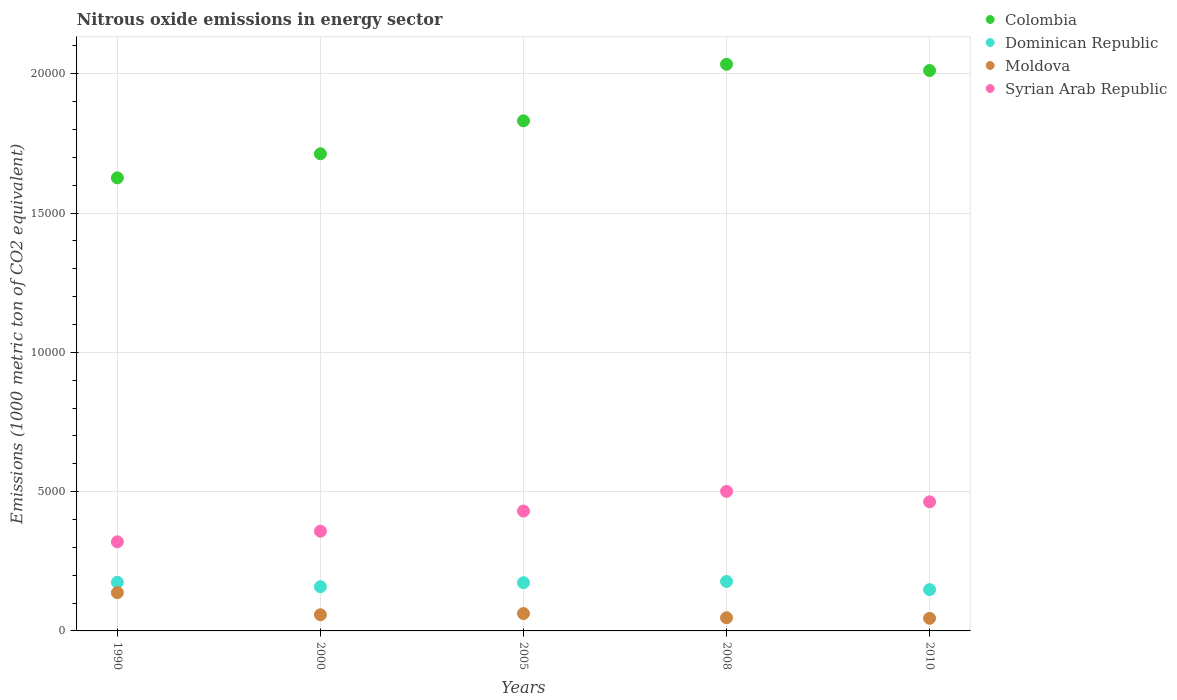How many different coloured dotlines are there?
Keep it short and to the point. 4. What is the amount of nitrous oxide emitted in Dominican Republic in 2005?
Your answer should be compact. 1731. Across all years, what is the maximum amount of nitrous oxide emitted in Moldova?
Give a very brief answer. 1373.3. Across all years, what is the minimum amount of nitrous oxide emitted in Dominican Republic?
Make the answer very short. 1481.5. In which year was the amount of nitrous oxide emitted in Colombia minimum?
Your answer should be very brief. 1990. What is the total amount of nitrous oxide emitted in Moldova in the graph?
Your response must be concise. 3502.6. What is the difference between the amount of nitrous oxide emitted in Colombia in 1990 and that in 2008?
Make the answer very short. -4077.5. What is the difference between the amount of nitrous oxide emitted in Colombia in 2005 and the amount of nitrous oxide emitted in Syrian Arab Republic in 2010?
Your response must be concise. 1.37e+04. What is the average amount of nitrous oxide emitted in Syrian Arab Republic per year?
Ensure brevity in your answer.  4144.66. In the year 2010, what is the difference between the amount of nitrous oxide emitted in Colombia and amount of nitrous oxide emitted in Syrian Arab Republic?
Give a very brief answer. 1.55e+04. In how many years, is the amount of nitrous oxide emitted in Syrian Arab Republic greater than 3000 1000 metric ton?
Keep it short and to the point. 5. What is the ratio of the amount of nitrous oxide emitted in Dominican Republic in 2005 to that in 2008?
Your answer should be very brief. 0.97. What is the difference between the highest and the second highest amount of nitrous oxide emitted in Syrian Arab Republic?
Your answer should be very brief. 376.8. What is the difference between the highest and the lowest amount of nitrous oxide emitted in Syrian Arab Republic?
Your answer should be compact. 1811.4. In how many years, is the amount of nitrous oxide emitted in Moldova greater than the average amount of nitrous oxide emitted in Moldova taken over all years?
Your answer should be very brief. 1. Is it the case that in every year, the sum of the amount of nitrous oxide emitted in Moldova and amount of nitrous oxide emitted in Dominican Republic  is greater than the sum of amount of nitrous oxide emitted in Colombia and amount of nitrous oxide emitted in Syrian Arab Republic?
Provide a succinct answer. No. Is it the case that in every year, the sum of the amount of nitrous oxide emitted in Moldova and amount of nitrous oxide emitted in Dominican Republic  is greater than the amount of nitrous oxide emitted in Syrian Arab Republic?
Ensure brevity in your answer.  No. Does the graph contain grids?
Give a very brief answer. Yes. How many legend labels are there?
Offer a terse response. 4. How are the legend labels stacked?
Your answer should be compact. Vertical. What is the title of the graph?
Your response must be concise. Nitrous oxide emissions in energy sector. What is the label or title of the Y-axis?
Provide a short and direct response. Emissions (1000 metric ton of CO2 equivalent). What is the Emissions (1000 metric ton of CO2 equivalent) in Colombia in 1990?
Offer a terse response. 1.63e+04. What is the Emissions (1000 metric ton of CO2 equivalent) in Dominican Republic in 1990?
Offer a very short reply. 1746.5. What is the Emissions (1000 metric ton of CO2 equivalent) of Moldova in 1990?
Your answer should be compact. 1373.3. What is the Emissions (1000 metric ton of CO2 equivalent) in Syrian Arab Republic in 1990?
Give a very brief answer. 3198.5. What is the Emissions (1000 metric ton of CO2 equivalent) of Colombia in 2000?
Offer a terse response. 1.71e+04. What is the Emissions (1000 metric ton of CO2 equivalent) of Dominican Republic in 2000?
Your answer should be compact. 1586.4. What is the Emissions (1000 metric ton of CO2 equivalent) in Moldova in 2000?
Provide a short and direct response. 579.9. What is the Emissions (1000 metric ton of CO2 equivalent) of Syrian Arab Republic in 2000?
Keep it short and to the point. 3579.1. What is the Emissions (1000 metric ton of CO2 equivalent) in Colombia in 2005?
Ensure brevity in your answer.  1.83e+04. What is the Emissions (1000 metric ton of CO2 equivalent) in Dominican Republic in 2005?
Your answer should be very brief. 1731. What is the Emissions (1000 metric ton of CO2 equivalent) of Moldova in 2005?
Provide a succinct answer. 624.1. What is the Emissions (1000 metric ton of CO2 equivalent) in Syrian Arab Republic in 2005?
Give a very brief answer. 4302.7. What is the Emissions (1000 metric ton of CO2 equivalent) of Colombia in 2008?
Your response must be concise. 2.03e+04. What is the Emissions (1000 metric ton of CO2 equivalent) of Dominican Republic in 2008?
Offer a very short reply. 1775.7. What is the Emissions (1000 metric ton of CO2 equivalent) in Moldova in 2008?
Your answer should be compact. 472.4. What is the Emissions (1000 metric ton of CO2 equivalent) of Syrian Arab Republic in 2008?
Provide a succinct answer. 5009.9. What is the Emissions (1000 metric ton of CO2 equivalent) of Colombia in 2010?
Offer a terse response. 2.01e+04. What is the Emissions (1000 metric ton of CO2 equivalent) of Dominican Republic in 2010?
Make the answer very short. 1481.5. What is the Emissions (1000 metric ton of CO2 equivalent) of Moldova in 2010?
Your answer should be very brief. 452.9. What is the Emissions (1000 metric ton of CO2 equivalent) in Syrian Arab Republic in 2010?
Your response must be concise. 4633.1. Across all years, what is the maximum Emissions (1000 metric ton of CO2 equivalent) of Colombia?
Ensure brevity in your answer.  2.03e+04. Across all years, what is the maximum Emissions (1000 metric ton of CO2 equivalent) of Dominican Republic?
Give a very brief answer. 1775.7. Across all years, what is the maximum Emissions (1000 metric ton of CO2 equivalent) in Moldova?
Make the answer very short. 1373.3. Across all years, what is the maximum Emissions (1000 metric ton of CO2 equivalent) in Syrian Arab Republic?
Offer a terse response. 5009.9. Across all years, what is the minimum Emissions (1000 metric ton of CO2 equivalent) of Colombia?
Ensure brevity in your answer.  1.63e+04. Across all years, what is the minimum Emissions (1000 metric ton of CO2 equivalent) in Dominican Republic?
Provide a succinct answer. 1481.5. Across all years, what is the minimum Emissions (1000 metric ton of CO2 equivalent) in Moldova?
Give a very brief answer. 452.9. Across all years, what is the minimum Emissions (1000 metric ton of CO2 equivalent) of Syrian Arab Republic?
Give a very brief answer. 3198.5. What is the total Emissions (1000 metric ton of CO2 equivalent) of Colombia in the graph?
Ensure brevity in your answer.  9.22e+04. What is the total Emissions (1000 metric ton of CO2 equivalent) of Dominican Republic in the graph?
Make the answer very short. 8321.1. What is the total Emissions (1000 metric ton of CO2 equivalent) in Moldova in the graph?
Provide a succinct answer. 3502.6. What is the total Emissions (1000 metric ton of CO2 equivalent) in Syrian Arab Republic in the graph?
Offer a very short reply. 2.07e+04. What is the difference between the Emissions (1000 metric ton of CO2 equivalent) in Colombia in 1990 and that in 2000?
Ensure brevity in your answer.  -864.4. What is the difference between the Emissions (1000 metric ton of CO2 equivalent) in Dominican Republic in 1990 and that in 2000?
Give a very brief answer. 160.1. What is the difference between the Emissions (1000 metric ton of CO2 equivalent) in Moldova in 1990 and that in 2000?
Keep it short and to the point. 793.4. What is the difference between the Emissions (1000 metric ton of CO2 equivalent) of Syrian Arab Republic in 1990 and that in 2000?
Your response must be concise. -380.6. What is the difference between the Emissions (1000 metric ton of CO2 equivalent) in Colombia in 1990 and that in 2005?
Keep it short and to the point. -2047.6. What is the difference between the Emissions (1000 metric ton of CO2 equivalent) in Moldova in 1990 and that in 2005?
Provide a succinct answer. 749.2. What is the difference between the Emissions (1000 metric ton of CO2 equivalent) in Syrian Arab Republic in 1990 and that in 2005?
Your answer should be very brief. -1104.2. What is the difference between the Emissions (1000 metric ton of CO2 equivalent) of Colombia in 1990 and that in 2008?
Give a very brief answer. -4077.5. What is the difference between the Emissions (1000 metric ton of CO2 equivalent) in Dominican Republic in 1990 and that in 2008?
Provide a succinct answer. -29.2. What is the difference between the Emissions (1000 metric ton of CO2 equivalent) in Moldova in 1990 and that in 2008?
Provide a short and direct response. 900.9. What is the difference between the Emissions (1000 metric ton of CO2 equivalent) in Syrian Arab Republic in 1990 and that in 2008?
Ensure brevity in your answer.  -1811.4. What is the difference between the Emissions (1000 metric ton of CO2 equivalent) in Colombia in 1990 and that in 2010?
Provide a short and direct response. -3854.4. What is the difference between the Emissions (1000 metric ton of CO2 equivalent) of Dominican Republic in 1990 and that in 2010?
Provide a succinct answer. 265. What is the difference between the Emissions (1000 metric ton of CO2 equivalent) of Moldova in 1990 and that in 2010?
Make the answer very short. 920.4. What is the difference between the Emissions (1000 metric ton of CO2 equivalent) in Syrian Arab Republic in 1990 and that in 2010?
Ensure brevity in your answer.  -1434.6. What is the difference between the Emissions (1000 metric ton of CO2 equivalent) in Colombia in 2000 and that in 2005?
Your answer should be very brief. -1183.2. What is the difference between the Emissions (1000 metric ton of CO2 equivalent) in Dominican Republic in 2000 and that in 2005?
Offer a terse response. -144.6. What is the difference between the Emissions (1000 metric ton of CO2 equivalent) of Moldova in 2000 and that in 2005?
Ensure brevity in your answer.  -44.2. What is the difference between the Emissions (1000 metric ton of CO2 equivalent) in Syrian Arab Republic in 2000 and that in 2005?
Your answer should be compact. -723.6. What is the difference between the Emissions (1000 metric ton of CO2 equivalent) in Colombia in 2000 and that in 2008?
Give a very brief answer. -3213.1. What is the difference between the Emissions (1000 metric ton of CO2 equivalent) in Dominican Republic in 2000 and that in 2008?
Give a very brief answer. -189.3. What is the difference between the Emissions (1000 metric ton of CO2 equivalent) in Moldova in 2000 and that in 2008?
Give a very brief answer. 107.5. What is the difference between the Emissions (1000 metric ton of CO2 equivalent) in Syrian Arab Republic in 2000 and that in 2008?
Offer a terse response. -1430.8. What is the difference between the Emissions (1000 metric ton of CO2 equivalent) of Colombia in 2000 and that in 2010?
Keep it short and to the point. -2990. What is the difference between the Emissions (1000 metric ton of CO2 equivalent) of Dominican Republic in 2000 and that in 2010?
Ensure brevity in your answer.  104.9. What is the difference between the Emissions (1000 metric ton of CO2 equivalent) in Moldova in 2000 and that in 2010?
Provide a succinct answer. 127. What is the difference between the Emissions (1000 metric ton of CO2 equivalent) in Syrian Arab Republic in 2000 and that in 2010?
Your answer should be very brief. -1054. What is the difference between the Emissions (1000 metric ton of CO2 equivalent) of Colombia in 2005 and that in 2008?
Make the answer very short. -2029.9. What is the difference between the Emissions (1000 metric ton of CO2 equivalent) of Dominican Republic in 2005 and that in 2008?
Ensure brevity in your answer.  -44.7. What is the difference between the Emissions (1000 metric ton of CO2 equivalent) in Moldova in 2005 and that in 2008?
Make the answer very short. 151.7. What is the difference between the Emissions (1000 metric ton of CO2 equivalent) in Syrian Arab Republic in 2005 and that in 2008?
Provide a short and direct response. -707.2. What is the difference between the Emissions (1000 metric ton of CO2 equivalent) in Colombia in 2005 and that in 2010?
Ensure brevity in your answer.  -1806.8. What is the difference between the Emissions (1000 metric ton of CO2 equivalent) of Dominican Republic in 2005 and that in 2010?
Your answer should be very brief. 249.5. What is the difference between the Emissions (1000 metric ton of CO2 equivalent) of Moldova in 2005 and that in 2010?
Provide a short and direct response. 171.2. What is the difference between the Emissions (1000 metric ton of CO2 equivalent) in Syrian Arab Republic in 2005 and that in 2010?
Offer a very short reply. -330.4. What is the difference between the Emissions (1000 metric ton of CO2 equivalent) in Colombia in 2008 and that in 2010?
Offer a terse response. 223.1. What is the difference between the Emissions (1000 metric ton of CO2 equivalent) in Dominican Republic in 2008 and that in 2010?
Your answer should be very brief. 294.2. What is the difference between the Emissions (1000 metric ton of CO2 equivalent) in Moldova in 2008 and that in 2010?
Offer a terse response. 19.5. What is the difference between the Emissions (1000 metric ton of CO2 equivalent) in Syrian Arab Republic in 2008 and that in 2010?
Your answer should be compact. 376.8. What is the difference between the Emissions (1000 metric ton of CO2 equivalent) of Colombia in 1990 and the Emissions (1000 metric ton of CO2 equivalent) of Dominican Republic in 2000?
Provide a short and direct response. 1.47e+04. What is the difference between the Emissions (1000 metric ton of CO2 equivalent) of Colombia in 1990 and the Emissions (1000 metric ton of CO2 equivalent) of Moldova in 2000?
Provide a succinct answer. 1.57e+04. What is the difference between the Emissions (1000 metric ton of CO2 equivalent) in Colombia in 1990 and the Emissions (1000 metric ton of CO2 equivalent) in Syrian Arab Republic in 2000?
Keep it short and to the point. 1.27e+04. What is the difference between the Emissions (1000 metric ton of CO2 equivalent) in Dominican Republic in 1990 and the Emissions (1000 metric ton of CO2 equivalent) in Moldova in 2000?
Give a very brief answer. 1166.6. What is the difference between the Emissions (1000 metric ton of CO2 equivalent) of Dominican Republic in 1990 and the Emissions (1000 metric ton of CO2 equivalent) of Syrian Arab Republic in 2000?
Provide a succinct answer. -1832.6. What is the difference between the Emissions (1000 metric ton of CO2 equivalent) in Moldova in 1990 and the Emissions (1000 metric ton of CO2 equivalent) in Syrian Arab Republic in 2000?
Provide a succinct answer. -2205.8. What is the difference between the Emissions (1000 metric ton of CO2 equivalent) of Colombia in 1990 and the Emissions (1000 metric ton of CO2 equivalent) of Dominican Republic in 2005?
Offer a terse response. 1.45e+04. What is the difference between the Emissions (1000 metric ton of CO2 equivalent) of Colombia in 1990 and the Emissions (1000 metric ton of CO2 equivalent) of Moldova in 2005?
Give a very brief answer. 1.56e+04. What is the difference between the Emissions (1000 metric ton of CO2 equivalent) of Colombia in 1990 and the Emissions (1000 metric ton of CO2 equivalent) of Syrian Arab Republic in 2005?
Your answer should be compact. 1.20e+04. What is the difference between the Emissions (1000 metric ton of CO2 equivalent) in Dominican Republic in 1990 and the Emissions (1000 metric ton of CO2 equivalent) in Moldova in 2005?
Offer a terse response. 1122.4. What is the difference between the Emissions (1000 metric ton of CO2 equivalent) of Dominican Republic in 1990 and the Emissions (1000 metric ton of CO2 equivalent) of Syrian Arab Republic in 2005?
Your answer should be compact. -2556.2. What is the difference between the Emissions (1000 metric ton of CO2 equivalent) in Moldova in 1990 and the Emissions (1000 metric ton of CO2 equivalent) in Syrian Arab Republic in 2005?
Ensure brevity in your answer.  -2929.4. What is the difference between the Emissions (1000 metric ton of CO2 equivalent) of Colombia in 1990 and the Emissions (1000 metric ton of CO2 equivalent) of Dominican Republic in 2008?
Make the answer very short. 1.45e+04. What is the difference between the Emissions (1000 metric ton of CO2 equivalent) of Colombia in 1990 and the Emissions (1000 metric ton of CO2 equivalent) of Moldova in 2008?
Make the answer very short. 1.58e+04. What is the difference between the Emissions (1000 metric ton of CO2 equivalent) of Colombia in 1990 and the Emissions (1000 metric ton of CO2 equivalent) of Syrian Arab Republic in 2008?
Your answer should be compact. 1.13e+04. What is the difference between the Emissions (1000 metric ton of CO2 equivalent) of Dominican Republic in 1990 and the Emissions (1000 metric ton of CO2 equivalent) of Moldova in 2008?
Your answer should be compact. 1274.1. What is the difference between the Emissions (1000 metric ton of CO2 equivalent) in Dominican Republic in 1990 and the Emissions (1000 metric ton of CO2 equivalent) in Syrian Arab Republic in 2008?
Keep it short and to the point. -3263.4. What is the difference between the Emissions (1000 metric ton of CO2 equivalent) of Moldova in 1990 and the Emissions (1000 metric ton of CO2 equivalent) of Syrian Arab Republic in 2008?
Keep it short and to the point. -3636.6. What is the difference between the Emissions (1000 metric ton of CO2 equivalent) in Colombia in 1990 and the Emissions (1000 metric ton of CO2 equivalent) in Dominican Republic in 2010?
Keep it short and to the point. 1.48e+04. What is the difference between the Emissions (1000 metric ton of CO2 equivalent) of Colombia in 1990 and the Emissions (1000 metric ton of CO2 equivalent) of Moldova in 2010?
Ensure brevity in your answer.  1.58e+04. What is the difference between the Emissions (1000 metric ton of CO2 equivalent) of Colombia in 1990 and the Emissions (1000 metric ton of CO2 equivalent) of Syrian Arab Republic in 2010?
Offer a terse response. 1.16e+04. What is the difference between the Emissions (1000 metric ton of CO2 equivalent) of Dominican Republic in 1990 and the Emissions (1000 metric ton of CO2 equivalent) of Moldova in 2010?
Ensure brevity in your answer.  1293.6. What is the difference between the Emissions (1000 metric ton of CO2 equivalent) of Dominican Republic in 1990 and the Emissions (1000 metric ton of CO2 equivalent) of Syrian Arab Republic in 2010?
Your answer should be very brief. -2886.6. What is the difference between the Emissions (1000 metric ton of CO2 equivalent) in Moldova in 1990 and the Emissions (1000 metric ton of CO2 equivalent) in Syrian Arab Republic in 2010?
Your response must be concise. -3259.8. What is the difference between the Emissions (1000 metric ton of CO2 equivalent) in Colombia in 2000 and the Emissions (1000 metric ton of CO2 equivalent) in Dominican Republic in 2005?
Keep it short and to the point. 1.54e+04. What is the difference between the Emissions (1000 metric ton of CO2 equivalent) of Colombia in 2000 and the Emissions (1000 metric ton of CO2 equivalent) of Moldova in 2005?
Offer a very short reply. 1.65e+04. What is the difference between the Emissions (1000 metric ton of CO2 equivalent) in Colombia in 2000 and the Emissions (1000 metric ton of CO2 equivalent) in Syrian Arab Republic in 2005?
Provide a succinct answer. 1.28e+04. What is the difference between the Emissions (1000 metric ton of CO2 equivalent) in Dominican Republic in 2000 and the Emissions (1000 metric ton of CO2 equivalent) in Moldova in 2005?
Your response must be concise. 962.3. What is the difference between the Emissions (1000 metric ton of CO2 equivalent) of Dominican Republic in 2000 and the Emissions (1000 metric ton of CO2 equivalent) of Syrian Arab Republic in 2005?
Provide a succinct answer. -2716.3. What is the difference between the Emissions (1000 metric ton of CO2 equivalent) in Moldova in 2000 and the Emissions (1000 metric ton of CO2 equivalent) in Syrian Arab Republic in 2005?
Offer a very short reply. -3722.8. What is the difference between the Emissions (1000 metric ton of CO2 equivalent) in Colombia in 2000 and the Emissions (1000 metric ton of CO2 equivalent) in Dominican Republic in 2008?
Ensure brevity in your answer.  1.54e+04. What is the difference between the Emissions (1000 metric ton of CO2 equivalent) in Colombia in 2000 and the Emissions (1000 metric ton of CO2 equivalent) in Moldova in 2008?
Your answer should be very brief. 1.67e+04. What is the difference between the Emissions (1000 metric ton of CO2 equivalent) of Colombia in 2000 and the Emissions (1000 metric ton of CO2 equivalent) of Syrian Arab Republic in 2008?
Offer a terse response. 1.21e+04. What is the difference between the Emissions (1000 metric ton of CO2 equivalent) of Dominican Republic in 2000 and the Emissions (1000 metric ton of CO2 equivalent) of Moldova in 2008?
Make the answer very short. 1114. What is the difference between the Emissions (1000 metric ton of CO2 equivalent) in Dominican Republic in 2000 and the Emissions (1000 metric ton of CO2 equivalent) in Syrian Arab Republic in 2008?
Make the answer very short. -3423.5. What is the difference between the Emissions (1000 metric ton of CO2 equivalent) of Moldova in 2000 and the Emissions (1000 metric ton of CO2 equivalent) of Syrian Arab Republic in 2008?
Ensure brevity in your answer.  -4430. What is the difference between the Emissions (1000 metric ton of CO2 equivalent) in Colombia in 2000 and the Emissions (1000 metric ton of CO2 equivalent) in Dominican Republic in 2010?
Give a very brief answer. 1.56e+04. What is the difference between the Emissions (1000 metric ton of CO2 equivalent) in Colombia in 2000 and the Emissions (1000 metric ton of CO2 equivalent) in Moldova in 2010?
Ensure brevity in your answer.  1.67e+04. What is the difference between the Emissions (1000 metric ton of CO2 equivalent) in Colombia in 2000 and the Emissions (1000 metric ton of CO2 equivalent) in Syrian Arab Republic in 2010?
Give a very brief answer. 1.25e+04. What is the difference between the Emissions (1000 metric ton of CO2 equivalent) of Dominican Republic in 2000 and the Emissions (1000 metric ton of CO2 equivalent) of Moldova in 2010?
Ensure brevity in your answer.  1133.5. What is the difference between the Emissions (1000 metric ton of CO2 equivalent) in Dominican Republic in 2000 and the Emissions (1000 metric ton of CO2 equivalent) in Syrian Arab Republic in 2010?
Your response must be concise. -3046.7. What is the difference between the Emissions (1000 metric ton of CO2 equivalent) in Moldova in 2000 and the Emissions (1000 metric ton of CO2 equivalent) in Syrian Arab Republic in 2010?
Offer a very short reply. -4053.2. What is the difference between the Emissions (1000 metric ton of CO2 equivalent) in Colombia in 2005 and the Emissions (1000 metric ton of CO2 equivalent) in Dominican Republic in 2008?
Give a very brief answer. 1.65e+04. What is the difference between the Emissions (1000 metric ton of CO2 equivalent) in Colombia in 2005 and the Emissions (1000 metric ton of CO2 equivalent) in Moldova in 2008?
Give a very brief answer. 1.78e+04. What is the difference between the Emissions (1000 metric ton of CO2 equivalent) of Colombia in 2005 and the Emissions (1000 metric ton of CO2 equivalent) of Syrian Arab Republic in 2008?
Offer a very short reply. 1.33e+04. What is the difference between the Emissions (1000 metric ton of CO2 equivalent) in Dominican Republic in 2005 and the Emissions (1000 metric ton of CO2 equivalent) in Moldova in 2008?
Provide a succinct answer. 1258.6. What is the difference between the Emissions (1000 metric ton of CO2 equivalent) in Dominican Republic in 2005 and the Emissions (1000 metric ton of CO2 equivalent) in Syrian Arab Republic in 2008?
Give a very brief answer. -3278.9. What is the difference between the Emissions (1000 metric ton of CO2 equivalent) of Moldova in 2005 and the Emissions (1000 metric ton of CO2 equivalent) of Syrian Arab Republic in 2008?
Keep it short and to the point. -4385.8. What is the difference between the Emissions (1000 metric ton of CO2 equivalent) in Colombia in 2005 and the Emissions (1000 metric ton of CO2 equivalent) in Dominican Republic in 2010?
Offer a very short reply. 1.68e+04. What is the difference between the Emissions (1000 metric ton of CO2 equivalent) in Colombia in 2005 and the Emissions (1000 metric ton of CO2 equivalent) in Moldova in 2010?
Your answer should be compact. 1.79e+04. What is the difference between the Emissions (1000 metric ton of CO2 equivalent) of Colombia in 2005 and the Emissions (1000 metric ton of CO2 equivalent) of Syrian Arab Republic in 2010?
Ensure brevity in your answer.  1.37e+04. What is the difference between the Emissions (1000 metric ton of CO2 equivalent) in Dominican Republic in 2005 and the Emissions (1000 metric ton of CO2 equivalent) in Moldova in 2010?
Your answer should be compact. 1278.1. What is the difference between the Emissions (1000 metric ton of CO2 equivalent) in Dominican Republic in 2005 and the Emissions (1000 metric ton of CO2 equivalent) in Syrian Arab Republic in 2010?
Offer a very short reply. -2902.1. What is the difference between the Emissions (1000 metric ton of CO2 equivalent) in Moldova in 2005 and the Emissions (1000 metric ton of CO2 equivalent) in Syrian Arab Republic in 2010?
Your answer should be compact. -4009. What is the difference between the Emissions (1000 metric ton of CO2 equivalent) of Colombia in 2008 and the Emissions (1000 metric ton of CO2 equivalent) of Dominican Republic in 2010?
Your answer should be very brief. 1.89e+04. What is the difference between the Emissions (1000 metric ton of CO2 equivalent) in Colombia in 2008 and the Emissions (1000 metric ton of CO2 equivalent) in Moldova in 2010?
Keep it short and to the point. 1.99e+04. What is the difference between the Emissions (1000 metric ton of CO2 equivalent) in Colombia in 2008 and the Emissions (1000 metric ton of CO2 equivalent) in Syrian Arab Republic in 2010?
Offer a very short reply. 1.57e+04. What is the difference between the Emissions (1000 metric ton of CO2 equivalent) of Dominican Republic in 2008 and the Emissions (1000 metric ton of CO2 equivalent) of Moldova in 2010?
Offer a very short reply. 1322.8. What is the difference between the Emissions (1000 metric ton of CO2 equivalent) in Dominican Republic in 2008 and the Emissions (1000 metric ton of CO2 equivalent) in Syrian Arab Republic in 2010?
Ensure brevity in your answer.  -2857.4. What is the difference between the Emissions (1000 metric ton of CO2 equivalent) of Moldova in 2008 and the Emissions (1000 metric ton of CO2 equivalent) of Syrian Arab Republic in 2010?
Your answer should be compact. -4160.7. What is the average Emissions (1000 metric ton of CO2 equivalent) of Colombia per year?
Provide a succinct answer. 1.84e+04. What is the average Emissions (1000 metric ton of CO2 equivalent) in Dominican Republic per year?
Your response must be concise. 1664.22. What is the average Emissions (1000 metric ton of CO2 equivalent) of Moldova per year?
Your answer should be very brief. 700.52. What is the average Emissions (1000 metric ton of CO2 equivalent) of Syrian Arab Republic per year?
Your answer should be compact. 4144.66. In the year 1990, what is the difference between the Emissions (1000 metric ton of CO2 equivalent) in Colombia and Emissions (1000 metric ton of CO2 equivalent) in Dominican Republic?
Give a very brief answer. 1.45e+04. In the year 1990, what is the difference between the Emissions (1000 metric ton of CO2 equivalent) of Colombia and Emissions (1000 metric ton of CO2 equivalent) of Moldova?
Keep it short and to the point. 1.49e+04. In the year 1990, what is the difference between the Emissions (1000 metric ton of CO2 equivalent) in Colombia and Emissions (1000 metric ton of CO2 equivalent) in Syrian Arab Republic?
Offer a terse response. 1.31e+04. In the year 1990, what is the difference between the Emissions (1000 metric ton of CO2 equivalent) of Dominican Republic and Emissions (1000 metric ton of CO2 equivalent) of Moldova?
Your response must be concise. 373.2. In the year 1990, what is the difference between the Emissions (1000 metric ton of CO2 equivalent) of Dominican Republic and Emissions (1000 metric ton of CO2 equivalent) of Syrian Arab Republic?
Offer a terse response. -1452. In the year 1990, what is the difference between the Emissions (1000 metric ton of CO2 equivalent) in Moldova and Emissions (1000 metric ton of CO2 equivalent) in Syrian Arab Republic?
Offer a very short reply. -1825.2. In the year 2000, what is the difference between the Emissions (1000 metric ton of CO2 equivalent) of Colombia and Emissions (1000 metric ton of CO2 equivalent) of Dominican Republic?
Your response must be concise. 1.55e+04. In the year 2000, what is the difference between the Emissions (1000 metric ton of CO2 equivalent) of Colombia and Emissions (1000 metric ton of CO2 equivalent) of Moldova?
Provide a succinct answer. 1.65e+04. In the year 2000, what is the difference between the Emissions (1000 metric ton of CO2 equivalent) in Colombia and Emissions (1000 metric ton of CO2 equivalent) in Syrian Arab Republic?
Your response must be concise. 1.35e+04. In the year 2000, what is the difference between the Emissions (1000 metric ton of CO2 equivalent) in Dominican Republic and Emissions (1000 metric ton of CO2 equivalent) in Moldova?
Your response must be concise. 1006.5. In the year 2000, what is the difference between the Emissions (1000 metric ton of CO2 equivalent) in Dominican Republic and Emissions (1000 metric ton of CO2 equivalent) in Syrian Arab Republic?
Give a very brief answer. -1992.7. In the year 2000, what is the difference between the Emissions (1000 metric ton of CO2 equivalent) in Moldova and Emissions (1000 metric ton of CO2 equivalent) in Syrian Arab Republic?
Provide a short and direct response. -2999.2. In the year 2005, what is the difference between the Emissions (1000 metric ton of CO2 equivalent) of Colombia and Emissions (1000 metric ton of CO2 equivalent) of Dominican Republic?
Give a very brief answer. 1.66e+04. In the year 2005, what is the difference between the Emissions (1000 metric ton of CO2 equivalent) of Colombia and Emissions (1000 metric ton of CO2 equivalent) of Moldova?
Give a very brief answer. 1.77e+04. In the year 2005, what is the difference between the Emissions (1000 metric ton of CO2 equivalent) in Colombia and Emissions (1000 metric ton of CO2 equivalent) in Syrian Arab Republic?
Provide a short and direct response. 1.40e+04. In the year 2005, what is the difference between the Emissions (1000 metric ton of CO2 equivalent) of Dominican Republic and Emissions (1000 metric ton of CO2 equivalent) of Moldova?
Offer a terse response. 1106.9. In the year 2005, what is the difference between the Emissions (1000 metric ton of CO2 equivalent) in Dominican Republic and Emissions (1000 metric ton of CO2 equivalent) in Syrian Arab Republic?
Keep it short and to the point. -2571.7. In the year 2005, what is the difference between the Emissions (1000 metric ton of CO2 equivalent) of Moldova and Emissions (1000 metric ton of CO2 equivalent) of Syrian Arab Republic?
Your answer should be very brief. -3678.6. In the year 2008, what is the difference between the Emissions (1000 metric ton of CO2 equivalent) in Colombia and Emissions (1000 metric ton of CO2 equivalent) in Dominican Republic?
Make the answer very short. 1.86e+04. In the year 2008, what is the difference between the Emissions (1000 metric ton of CO2 equivalent) in Colombia and Emissions (1000 metric ton of CO2 equivalent) in Moldova?
Your answer should be compact. 1.99e+04. In the year 2008, what is the difference between the Emissions (1000 metric ton of CO2 equivalent) of Colombia and Emissions (1000 metric ton of CO2 equivalent) of Syrian Arab Republic?
Provide a short and direct response. 1.53e+04. In the year 2008, what is the difference between the Emissions (1000 metric ton of CO2 equivalent) in Dominican Republic and Emissions (1000 metric ton of CO2 equivalent) in Moldova?
Provide a succinct answer. 1303.3. In the year 2008, what is the difference between the Emissions (1000 metric ton of CO2 equivalent) in Dominican Republic and Emissions (1000 metric ton of CO2 equivalent) in Syrian Arab Republic?
Offer a very short reply. -3234.2. In the year 2008, what is the difference between the Emissions (1000 metric ton of CO2 equivalent) in Moldova and Emissions (1000 metric ton of CO2 equivalent) in Syrian Arab Republic?
Your response must be concise. -4537.5. In the year 2010, what is the difference between the Emissions (1000 metric ton of CO2 equivalent) in Colombia and Emissions (1000 metric ton of CO2 equivalent) in Dominican Republic?
Provide a succinct answer. 1.86e+04. In the year 2010, what is the difference between the Emissions (1000 metric ton of CO2 equivalent) in Colombia and Emissions (1000 metric ton of CO2 equivalent) in Moldova?
Provide a succinct answer. 1.97e+04. In the year 2010, what is the difference between the Emissions (1000 metric ton of CO2 equivalent) in Colombia and Emissions (1000 metric ton of CO2 equivalent) in Syrian Arab Republic?
Provide a short and direct response. 1.55e+04. In the year 2010, what is the difference between the Emissions (1000 metric ton of CO2 equivalent) in Dominican Republic and Emissions (1000 metric ton of CO2 equivalent) in Moldova?
Give a very brief answer. 1028.6. In the year 2010, what is the difference between the Emissions (1000 metric ton of CO2 equivalent) in Dominican Republic and Emissions (1000 metric ton of CO2 equivalent) in Syrian Arab Republic?
Your answer should be compact. -3151.6. In the year 2010, what is the difference between the Emissions (1000 metric ton of CO2 equivalent) in Moldova and Emissions (1000 metric ton of CO2 equivalent) in Syrian Arab Republic?
Your response must be concise. -4180.2. What is the ratio of the Emissions (1000 metric ton of CO2 equivalent) in Colombia in 1990 to that in 2000?
Your response must be concise. 0.95. What is the ratio of the Emissions (1000 metric ton of CO2 equivalent) of Dominican Republic in 1990 to that in 2000?
Your response must be concise. 1.1. What is the ratio of the Emissions (1000 metric ton of CO2 equivalent) of Moldova in 1990 to that in 2000?
Make the answer very short. 2.37. What is the ratio of the Emissions (1000 metric ton of CO2 equivalent) in Syrian Arab Republic in 1990 to that in 2000?
Your answer should be compact. 0.89. What is the ratio of the Emissions (1000 metric ton of CO2 equivalent) of Colombia in 1990 to that in 2005?
Your response must be concise. 0.89. What is the ratio of the Emissions (1000 metric ton of CO2 equivalent) of Moldova in 1990 to that in 2005?
Your answer should be compact. 2.2. What is the ratio of the Emissions (1000 metric ton of CO2 equivalent) in Syrian Arab Republic in 1990 to that in 2005?
Your answer should be very brief. 0.74. What is the ratio of the Emissions (1000 metric ton of CO2 equivalent) in Colombia in 1990 to that in 2008?
Keep it short and to the point. 0.8. What is the ratio of the Emissions (1000 metric ton of CO2 equivalent) of Dominican Republic in 1990 to that in 2008?
Provide a succinct answer. 0.98. What is the ratio of the Emissions (1000 metric ton of CO2 equivalent) of Moldova in 1990 to that in 2008?
Provide a succinct answer. 2.91. What is the ratio of the Emissions (1000 metric ton of CO2 equivalent) of Syrian Arab Republic in 1990 to that in 2008?
Offer a terse response. 0.64. What is the ratio of the Emissions (1000 metric ton of CO2 equivalent) of Colombia in 1990 to that in 2010?
Your answer should be compact. 0.81. What is the ratio of the Emissions (1000 metric ton of CO2 equivalent) in Dominican Republic in 1990 to that in 2010?
Offer a very short reply. 1.18. What is the ratio of the Emissions (1000 metric ton of CO2 equivalent) in Moldova in 1990 to that in 2010?
Offer a very short reply. 3.03. What is the ratio of the Emissions (1000 metric ton of CO2 equivalent) of Syrian Arab Republic in 1990 to that in 2010?
Your answer should be compact. 0.69. What is the ratio of the Emissions (1000 metric ton of CO2 equivalent) in Colombia in 2000 to that in 2005?
Provide a short and direct response. 0.94. What is the ratio of the Emissions (1000 metric ton of CO2 equivalent) in Dominican Republic in 2000 to that in 2005?
Your answer should be compact. 0.92. What is the ratio of the Emissions (1000 metric ton of CO2 equivalent) in Moldova in 2000 to that in 2005?
Your answer should be compact. 0.93. What is the ratio of the Emissions (1000 metric ton of CO2 equivalent) of Syrian Arab Republic in 2000 to that in 2005?
Your response must be concise. 0.83. What is the ratio of the Emissions (1000 metric ton of CO2 equivalent) in Colombia in 2000 to that in 2008?
Your response must be concise. 0.84. What is the ratio of the Emissions (1000 metric ton of CO2 equivalent) in Dominican Republic in 2000 to that in 2008?
Your response must be concise. 0.89. What is the ratio of the Emissions (1000 metric ton of CO2 equivalent) of Moldova in 2000 to that in 2008?
Your response must be concise. 1.23. What is the ratio of the Emissions (1000 metric ton of CO2 equivalent) of Syrian Arab Republic in 2000 to that in 2008?
Keep it short and to the point. 0.71. What is the ratio of the Emissions (1000 metric ton of CO2 equivalent) of Colombia in 2000 to that in 2010?
Provide a succinct answer. 0.85. What is the ratio of the Emissions (1000 metric ton of CO2 equivalent) in Dominican Republic in 2000 to that in 2010?
Offer a terse response. 1.07. What is the ratio of the Emissions (1000 metric ton of CO2 equivalent) of Moldova in 2000 to that in 2010?
Make the answer very short. 1.28. What is the ratio of the Emissions (1000 metric ton of CO2 equivalent) of Syrian Arab Republic in 2000 to that in 2010?
Provide a short and direct response. 0.77. What is the ratio of the Emissions (1000 metric ton of CO2 equivalent) of Colombia in 2005 to that in 2008?
Provide a succinct answer. 0.9. What is the ratio of the Emissions (1000 metric ton of CO2 equivalent) in Dominican Republic in 2005 to that in 2008?
Keep it short and to the point. 0.97. What is the ratio of the Emissions (1000 metric ton of CO2 equivalent) of Moldova in 2005 to that in 2008?
Ensure brevity in your answer.  1.32. What is the ratio of the Emissions (1000 metric ton of CO2 equivalent) in Syrian Arab Republic in 2005 to that in 2008?
Ensure brevity in your answer.  0.86. What is the ratio of the Emissions (1000 metric ton of CO2 equivalent) in Colombia in 2005 to that in 2010?
Offer a terse response. 0.91. What is the ratio of the Emissions (1000 metric ton of CO2 equivalent) in Dominican Republic in 2005 to that in 2010?
Make the answer very short. 1.17. What is the ratio of the Emissions (1000 metric ton of CO2 equivalent) of Moldova in 2005 to that in 2010?
Your answer should be compact. 1.38. What is the ratio of the Emissions (1000 metric ton of CO2 equivalent) of Syrian Arab Republic in 2005 to that in 2010?
Your answer should be compact. 0.93. What is the ratio of the Emissions (1000 metric ton of CO2 equivalent) in Colombia in 2008 to that in 2010?
Your answer should be compact. 1.01. What is the ratio of the Emissions (1000 metric ton of CO2 equivalent) in Dominican Republic in 2008 to that in 2010?
Offer a terse response. 1.2. What is the ratio of the Emissions (1000 metric ton of CO2 equivalent) of Moldova in 2008 to that in 2010?
Your answer should be very brief. 1.04. What is the ratio of the Emissions (1000 metric ton of CO2 equivalent) of Syrian Arab Republic in 2008 to that in 2010?
Keep it short and to the point. 1.08. What is the difference between the highest and the second highest Emissions (1000 metric ton of CO2 equivalent) of Colombia?
Your answer should be very brief. 223.1. What is the difference between the highest and the second highest Emissions (1000 metric ton of CO2 equivalent) of Dominican Republic?
Your answer should be compact. 29.2. What is the difference between the highest and the second highest Emissions (1000 metric ton of CO2 equivalent) of Moldova?
Make the answer very short. 749.2. What is the difference between the highest and the second highest Emissions (1000 metric ton of CO2 equivalent) in Syrian Arab Republic?
Make the answer very short. 376.8. What is the difference between the highest and the lowest Emissions (1000 metric ton of CO2 equivalent) in Colombia?
Offer a terse response. 4077.5. What is the difference between the highest and the lowest Emissions (1000 metric ton of CO2 equivalent) in Dominican Republic?
Offer a very short reply. 294.2. What is the difference between the highest and the lowest Emissions (1000 metric ton of CO2 equivalent) in Moldova?
Your answer should be compact. 920.4. What is the difference between the highest and the lowest Emissions (1000 metric ton of CO2 equivalent) of Syrian Arab Republic?
Your answer should be compact. 1811.4. 